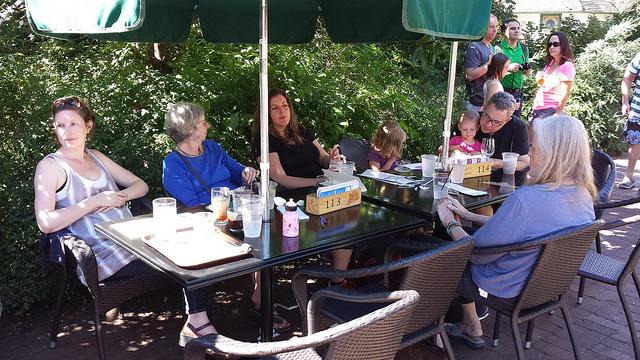What is on the woman's head?
Concise answer only. Sunglasses. Where was this picture taken?
Give a very brief answer. Outside. How many children are in this picture?
Be succinct. 3. What color are the umbrellas?
Quick response, please. Green. 